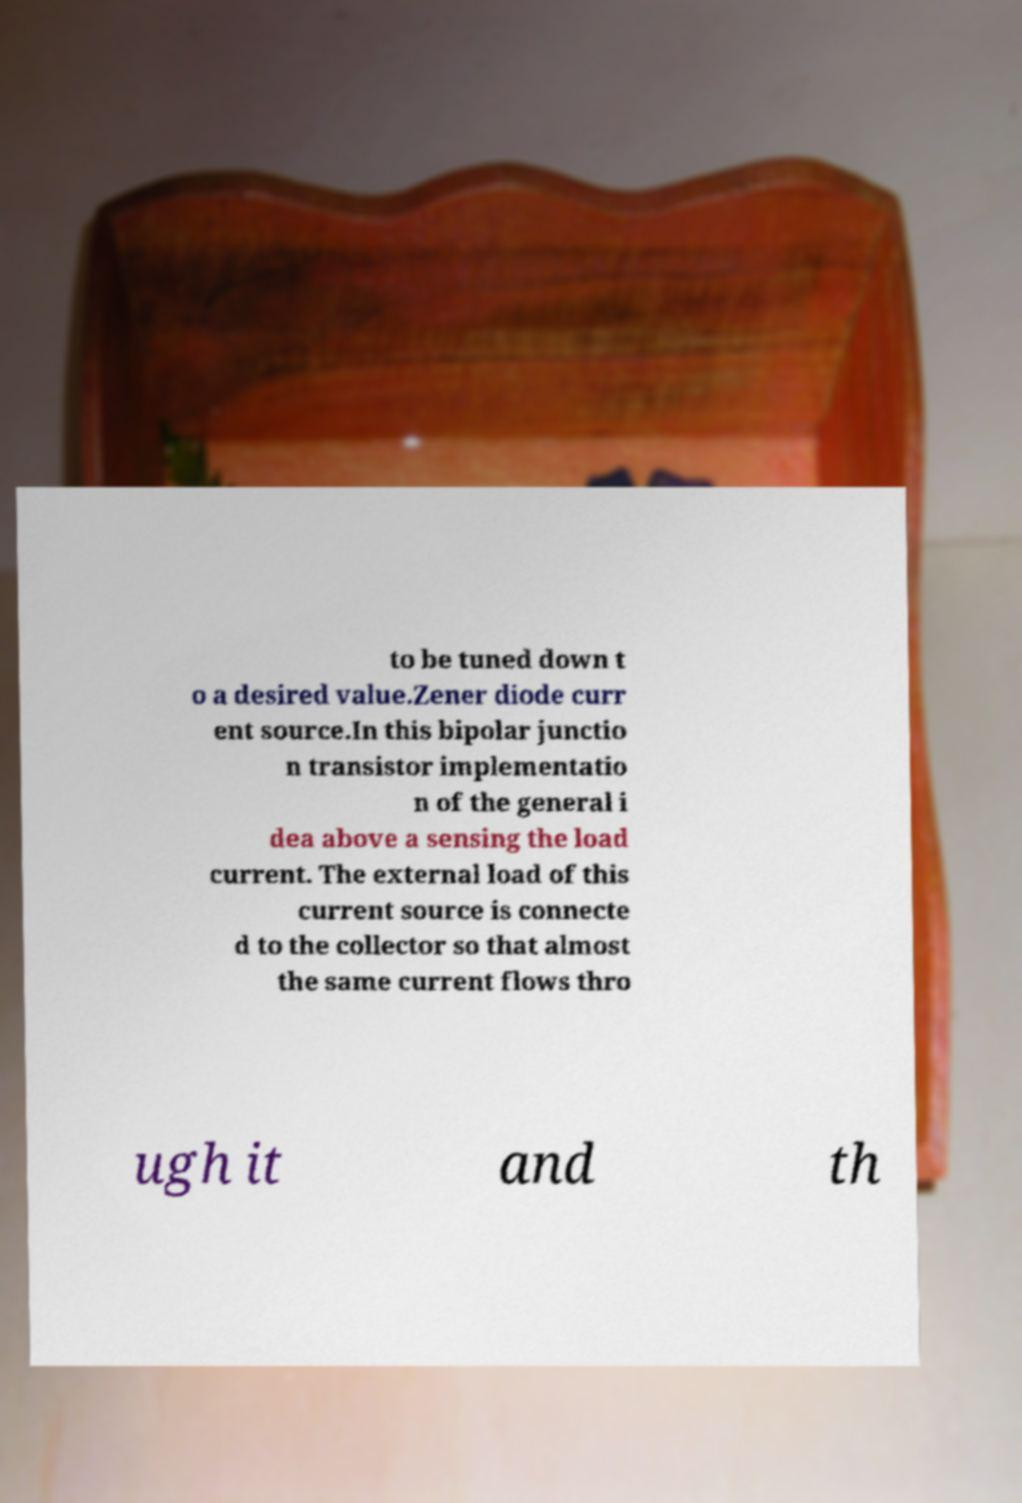For documentation purposes, I need the text within this image transcribed. Could you provide that? to be tuned down t o a desired value.Zener diode curr ent source.In this bipolar junctio n transistor implementatio n of the general i dea above a sensing the load current. The external load of this current source is connecte d to the collector so that almost the same current flows thro ugh it and th 